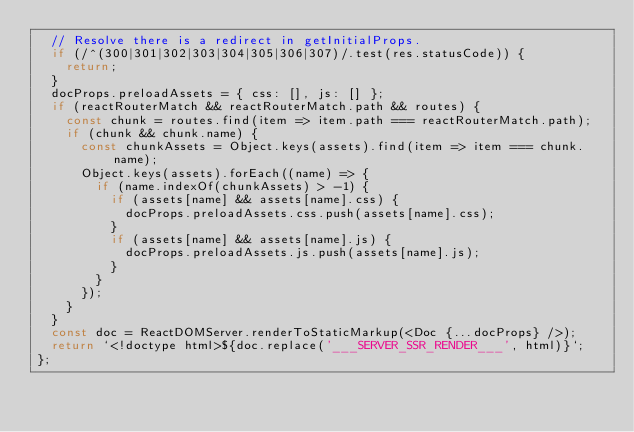Convert code to text. <code><loc_0><loc_0><loc_500><loc_500><_JavaScript_>  // Resolve there is a redirect in getInitialProps.
  if (/^(300|301|302|303|304|305|306|307)/.test(res.statusCode)) {
    return;
  }
  docProps.preloadAssets = { css: [], js: [] };
  if (reactRouterMatch && reactRouterMatch.path && routes) {
    const chunk = routes.find(item => item.path === reactRouterMatch.path);
    if (chunk && chunk.name) {
      const chunkAssets = Object.keys(assets).find(item => item === chunk.name);
      Object.keys(assets).forEach((name) => {
        if (name.indexOf(chunkAssets) > -1) {
          if (assets[name] && assets[name].css) {
            docProps.preloadAssets.css.push(assets[name].css);
          }
          if (assets[name] && assets[name].js) {
            docProps.preloadAssets.js.push(assets[name].js);
          }
        }
      });
    }
  }
  const doc = ReactDOMServer.renderToStaticMarkup(<Doc {...docProps} />);
  return `<!doctype html>${doc.replace('___SERVER_SSR_RENDER___', html)}`;
};
</code> 